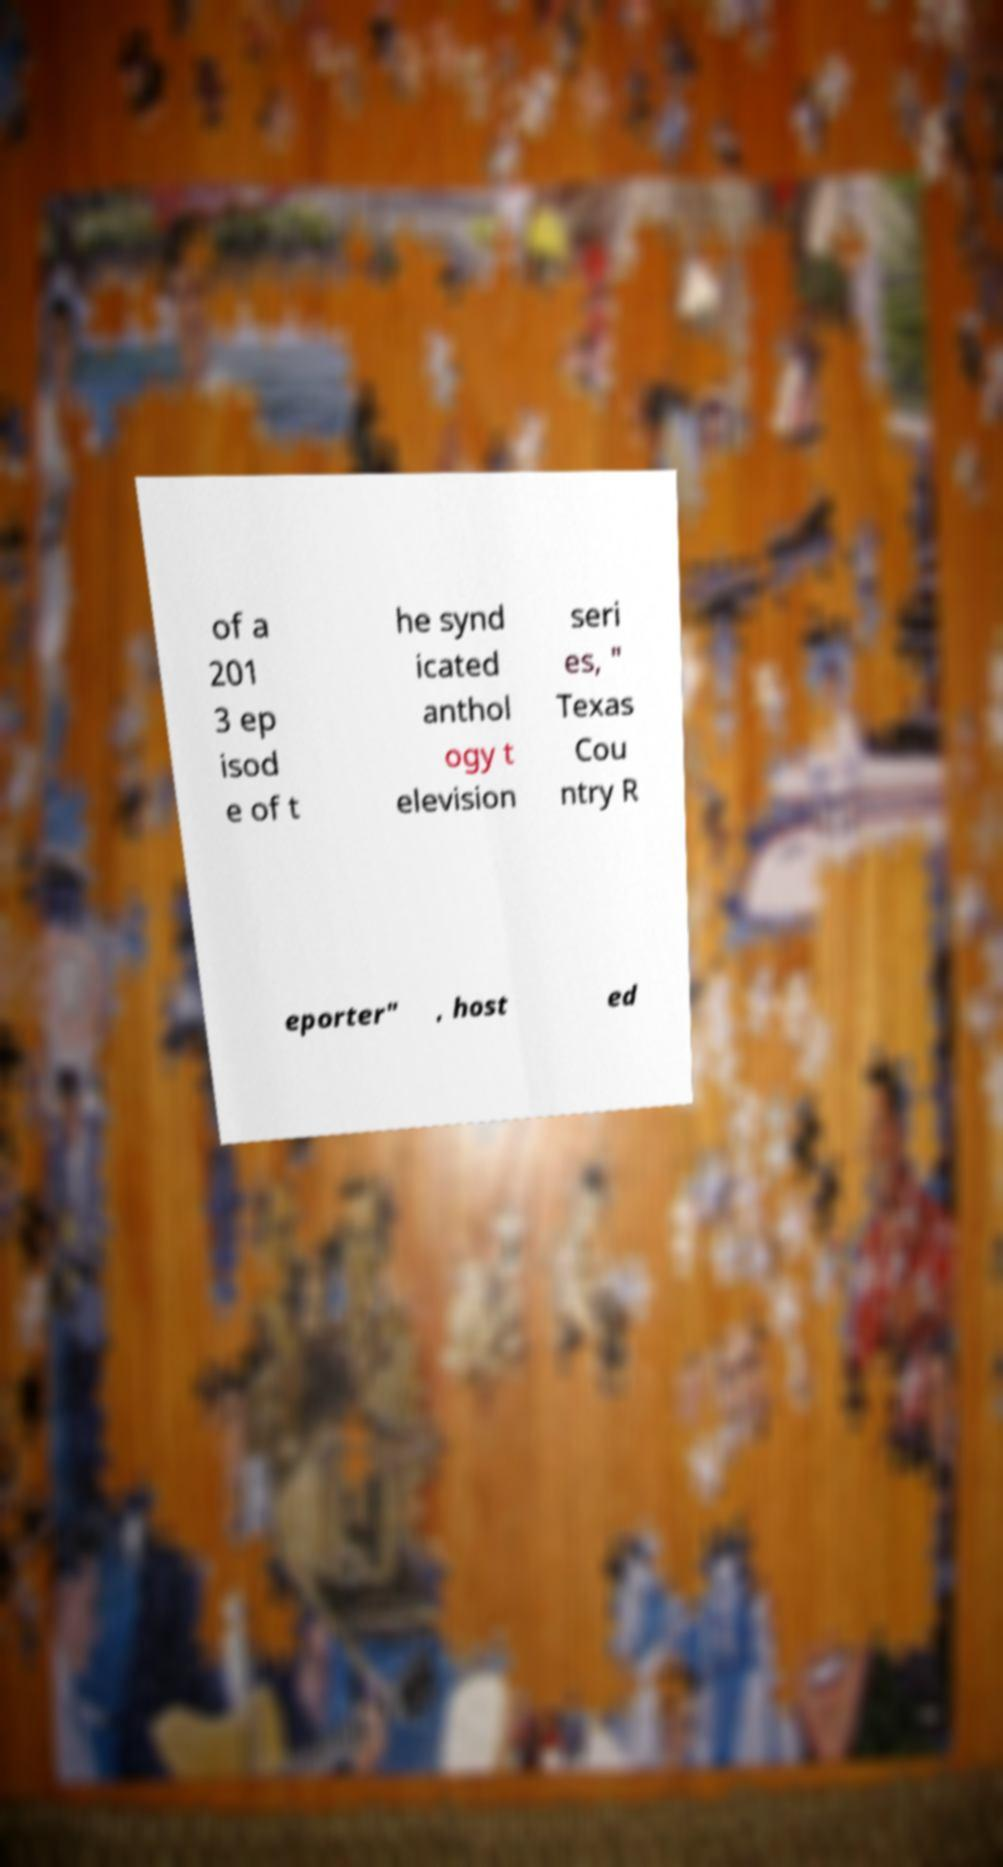Can you read and provide the text displayed in the image?This photo seems to have some interesting text. Can you extract and type it out for me? of a 201 3 ep isod e of t he synd icated anthol ogy t elevision seri es, " Texas Cou ntry R eporter" , host ed 